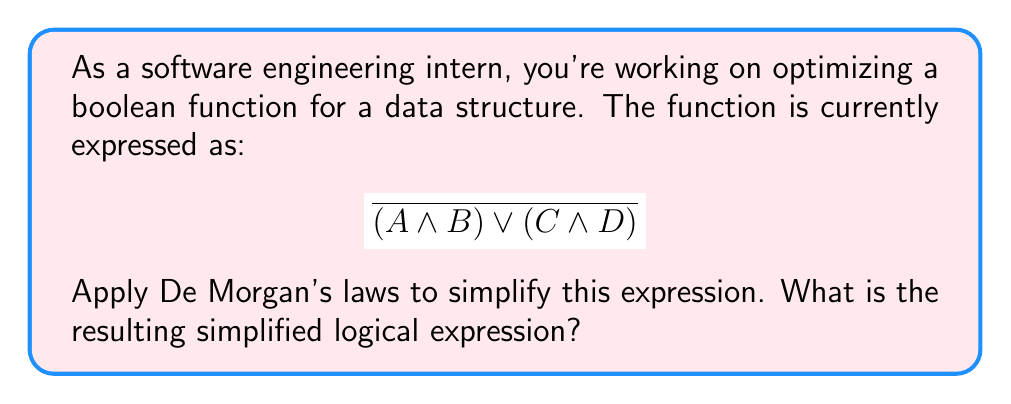Provide a solution to this math problem. Let's apply De Morgan's laws step by step to simplify this expression:

1) First, recall De Morgan's laws:
   - $\overline{P \lor Q} = \overline{P} \land \overline{Q}$
   - $\overline{P \land Q} = \overline{P} \lor \overline{Q}$

2) In our expression, we have:
   $$ \overline{(A \land B) \lor (C \land D)} $$

3) This matches the form of the first De Morgan's law, where:
   $P = (A \land B)$ and $Q = (C \land D)$

4) Applying the law:
   $$ \overline{(A \land B)} \land \overline{(C \land D)} $$

5) Now we can apply the second De Morgan's law to each part:
   For $\overline{(A \land B)}$:
   $$ (\overline{A} \lor \overline{B}) $$
   
   For $\overline{(C \land D)}$:
   $$ (\overline{C} \lor \overline{D}) $$

6) Putting it all together:
   $$ (\overline{A} \lor \overline{B}) \land (\overline{C} \lor \overline{D}) $$

This is our final simplified expression.
Answer: $$ (\overline{A} \lor \overline{B}) \land (\overline{C} \lor \overline{D}) $$ 